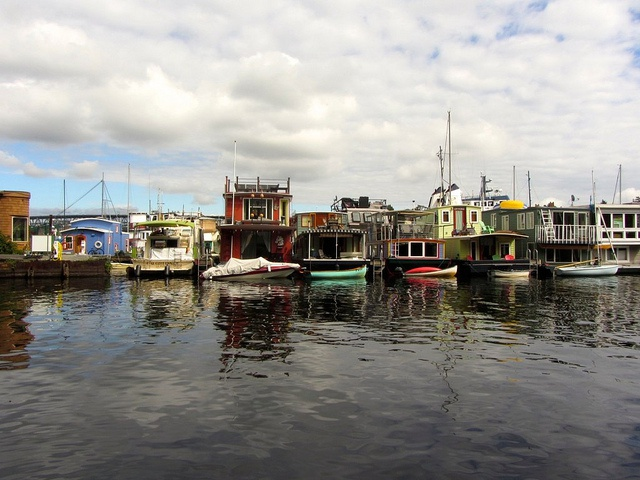Describe the objects in this image and their specific colors. I can see boat in lightgray, black, gray, darkgray, and darkgreen tones, boat in lightgray, black, ivory, olive, and khaki tones, boat in lightgray, black, gray, and maroon tones, boat in lightgray, beige, tan, black, and olive tones, and boat in lightgray, gray, and darkgray tones in this image. 